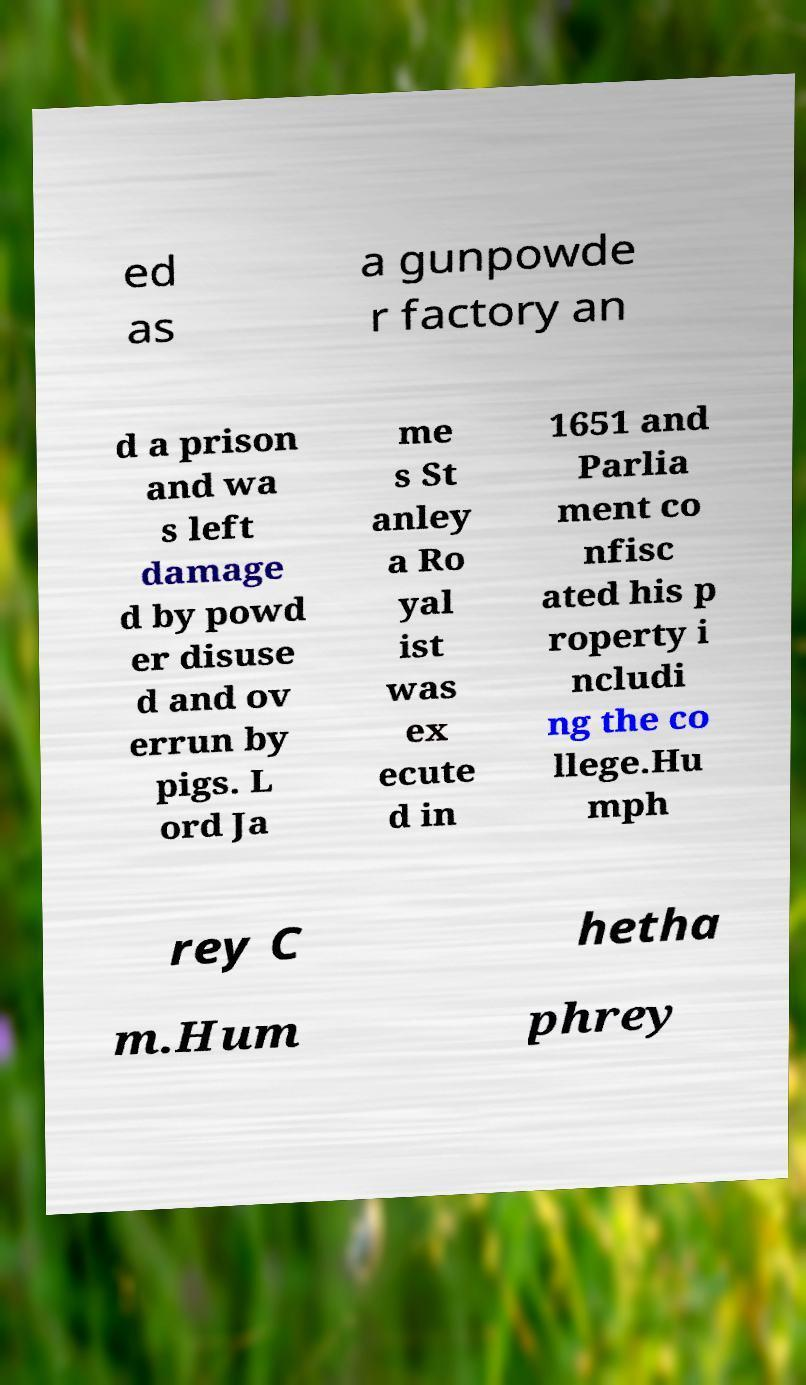Can you accurately transcribe the text from the provided image for me? ed as a gunpowde r factory an d a prison and wa s left damage d by powd er disuse d and ov errun by pigs. L ord Ja me s St anley a Ro yal ist was ex ecute d in 1651 and Parlia ment co nfisc ated his p roperty i ncludi ng the co llege.Hu mph rey C hetha m.Hum phrey 